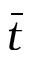Convert formula to latex. <formula><loc_0><loc_0><loc_500><loc_500>\bar { t }</formula> 